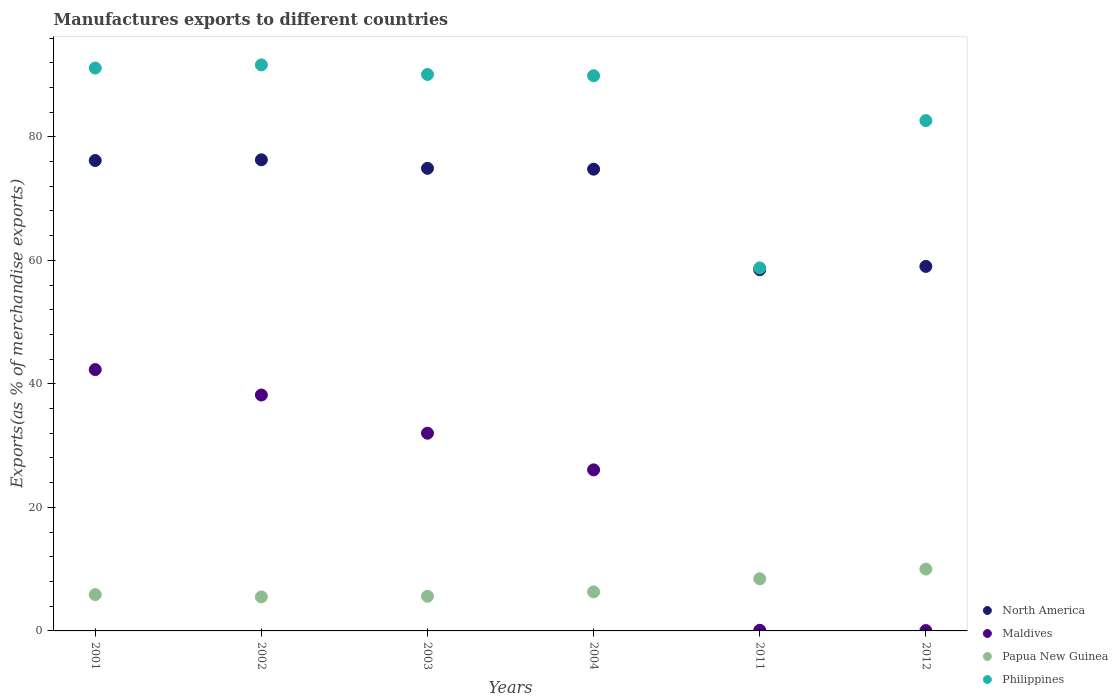How many different coloured dotlines are there?
Keep it short and to the point. 4. Is the number of dotlines equal to the number of legend labels?
Provide a succinct answer. Yes. What is the percentage of exports to different countries in Philippines in 2012?
Your answer should be compact. 82.63. Across all years, what is the maximum percentage of exports to different countries in Philippines?
Keep it short and to the point. 91.66. Across all years, what is the minimum percentage of exports to different countries in North America?
Offer a very short reply. 58.49. In which year was the percentage of exports to different countries in Papua New Guinea minimum?
Offer a very short reply. 2002. What is the total percentage of exports to different countries in Philippines in the graph?
Keep it short and to the point. 504.21. What is the difference between the percentage of exports to different countries in Philippines in 2003 and that in 2011?
Your answer should be compact. 31.33. What is the difference between the percentage of exports to different countries in Maldives in 2002 and the percentage of exports to different countries in North America in 2012?
Make the answer very short. -20.82. What is the average percentage of exports to different countries in Philippines per year?
Your answer should be compact. 84.04. In the year 2004, what is the difference between the percentage of exports to different countries in Maldives and percentage of exports to different countries in North America?
Provide a short and direct response. -48.69. What is the ratio of the percentage of exports to different countries in Papua New Guinea in 2001 to that in 2012?
Keep it short and to the point. 0.59. What is the difference between the highest and the second highest percentage of exports to different countries in Philippines?
Your answer should be compact. 0.52. What is the difference between the highest and the lowest percentage of exports to different countries in North America?
Offer a terse response. 17.79. In how many years, is the percentage of exports to different countries in Philippines greater than the average percentage of exports to different countries in Philippines taken over all years?
Your answer should be compact. 4. Is the sum of the percentage of exports to different countries in Papua New Guinea in 2004 and 2012 greater than the maximum percentage of exports to different countries in Philippines across all years?
Provide a short and direct response. No. Is it the case that in every year, the sum of the percentage of exports to different countries in North America and percentage of exports to different countries in Papua New Guinea  is greater than the sum of percentage of exports to different countries in Philippines and percentage of exports to different countries in Maldives?
Offer a very short reply. No. Is the percentage of exports to different countries in Maldives strictly less than the percentage of exports to different countries in Philippines over the years?
Your answer should be very brief. Yes. Does the graph contain grids?
Ensure brevity in your answer.  No. Where does the legend appear in the graph?
Your answer should be very brief. Bottom right. How are the legend labels stacked?
Ensure brevity in your answer.  Vertical. What is the title of the graph?
Offer a very short reply. Manufactures exports to different countries. Does "Zambia" appear as one of the legend labels in the graph?
Your answer should be compact. No. What is the label or title of the X-axis?
Provide a succinct answer. Years. What is the label or title of the Y-axis?
Give a very brief answer. Exports(as % of merchandise exports). What is the Exports(as % of merchandise exports) in North America in 2001?
Keep it short and to the point. 76.17. What is the Exports(as % of merchandise exports) in Maldives in 2001?
Offer a terse response. 42.32. What is the Exports(as % of merchandise exports) in Papua New Guinea in 2001?
Your answer should be compact. 5.88. What is the Exports(as % of merchandise exports) in Philippines in 2001?
Keep it short and to the point. 91.14. What is the Exports(as % of merchandise exports) in North America in 2002?
Make the answer very short. 76.29. What is the Exports(as % of merchandise exports) of Maldives in 2002?
Keep it short and to the point. 38.2. What is the Exports(as % of merchandise exports) of Papua New Guinea in 2002?
Your response must be concise. 5.51. What is the Exports(as % of merchandise exports) of Philippines in 2002?
Your answer should be very brief. 91.66. What is the Exports(as % of merchandise exports) of North America in 2003?
Give a very brief answer. 74.9. What is the Exports(as % of merchandise exports) of Maldives in 2003?
Keep it short and to the point. 32.02. What is the Exports(as % of merchandise exports) in Papua New Guinea in 2003?
Give a very brief answer. 5.61. What is the Exports(as % of merchandise exports) in Philippines in 2003?
Ensure brevity in your answer.  90.11. What is the Exports(as % of merchandise exports) of North America in 2004?
Offer a terse response. 74.76. What is the Exports(as % of merchandise exports) in Maldives in 2004?
Provide a short and direct response. 26.08. What is the Exports(as % of merchandise exports) of Papua New Guinea in 2004?
Keep it short and to the point. 6.32. What is the Exports(as % of merchandise exports) in Philippines in 2004?
Offer a very short reply. 89.9. What is the Exports(as % of merchandise exports) in North America in 2011?
Make the answer very short. 58.49. What is the Exports(as % of merchandise exports) of Maldives in 2011?
Offer a very short reply. 0.1. What is the Exports(as % of merchandise exports) in Papua New Guinea in 2011?
Your answer should be very brief. 8.44. What is the Exports(as % of merchandise exports) of Philippines in 2011?
Your answer should be very brief. 58.78. What is the Exports(as % of merchandise exports) of North America in 2012?
Keep it short and to the point. 59.02. What is the Exports(as % of merchandise exports) of Maldives in 2012?
Provide a succinct answer. 0.06. What is the Exports(as % of merchandise exports) of Papua New Guinea in 2012?
Offer a terse response. 10.02. What is the Exports(as % of merchandise exports) of Philippines in 2012?
Offer a very short reply. 82.63. Across all years, what is the maximum Exports(as % of merchandise exports) in North America?
Offer a very short reply. 76.29. Across all years, what is the maximum Exports(as % of merchandise exports) in Maldives?
Provide a succinct answer. 42.32. Across all years, what is the maximum Exports(as % of merchandise exports) of Papua New Guinea?
Your answer should be compact. 10.02. Across all years, what is the maximum Exports(as % of merchandise exports) in Philippines?
Your answer should be very brief. 91.66. Across all years, what is the minimum Exports(as % of merchandise exports) of North America?
Give a very brief answer. 58.49. Across all years, what is the minimum Exports(as % of merchandise exports) of Maldives?
Provide a short and direct response. 0.06. Across all years, what is the minimum Exports(as % of merchandise exports) of Papua New Guinea?
Provide a short and direct response. 5.51. Across all years, what is the minimum Exports(as % of merchandise exports) in Philippines?
Keep it short and to the point. 58.78. What is the total Exports(as % of merchandise exports) of North America in the graph?
Make the answer very short. 419.64. What is the total Exports(as % of merchandise exports) in Maldives in the graph?
Offer a terse response. 138.78. What is the total Exports(as % of merchandise exports) in Papua New Guinea in the graph?
Ensure brevity in your answer.  41.78. What is the total Exports(as % of merchandise exports) in Philippines in the graph?
Ensure brevity in your answer.  504.21. What is the difference between the Exports(as % of merchandise exports) of North America in 2001 and that in 2002?
Keep it short and to the point. -0.12. What is the difference between the Exports(as % of merchandise exports) of Maldives in 2001 and that in 2002?
Your response must be concise. 4.12. What is the difference between the Exports(as % of merchandise exports) of Papua New Guinea in 2001 and that in 2002?
Give a very brief answer. 0.37. What is the difference between the Exports(as % of merchandise exports) in Philippines in 2001 and that in 2002?
Offer a terse response. -0.52. What is the difference between the Exports(as % of merchandise exports) in North America in 2001 and that in 2003?
Your answer should be compact. 1.27. What is the difference between the Exports(as % of merchandise exports) in Maldives in 2001 and that in 2003?
Make the answer very short. 10.3. What is the difference between the Exports(as % of merchandise exports) of Papua New Guinea in 2001 and that in 2003?
Your response must be concise. 0.28. What is the difference between the Exports(as % of merchandise exports) in Philippines in 2001 and that in 2003?
Offer a very short reply. 1.04. What is the difference between the Exports(as % of merchandise exports) in North America in 2001 and that in 2004?
Provide a succinct answer. 1.4. What is the difference between the Exports(as % of merchandise exports) of Maldives in 2001 and that in 2004?
Your response must be concise. 16.24. What is the difference between the Exports(as % of merchandise exports) in Papua New Guinea in 2001 and that in 2004?
Make the answer very short. -0.44. What is the difference between the Exports(as % of merchandise exports) of Philippines in 2001 and that in 2004?
Offer a terse response. 1.25. What is the difference between the Exports(as % of merchandise exports) of North America in 2001 and that in 2011?
Provide a short and direct response. 17.68. What is the difference between the Exports(as % of merchandise exports) of Maldives in 2001 and that in 2011?
Provide a succinct answer. 42.22. What is the difference between the Exports(as % of merchandise exports) in Papua New Guinea in 2001 and that in 2011?
Keep it short and to the point. -2.56. What is the difference between the Exports(as % of merchandise exports) in Philippines in 2001 and that in 2011?
Ensure brevity in your answer.  32.36. What is the difference between the Exports(as % of merchandise exports) of North America in 2001 and that in 2012?
Provide a short and direct response. 17.15. What is the difference between the Exports(as % of merchandise exports) in Maldives in 2001 and that in 2012?
Make the answer very short. 42.26. What is the difference between the Exports(as % of merchandise exports) in Papua New Guinea in 2001 and that in 2012?
Provide a succinct answer. -4.13. What is the difference between the Exports(as % of merchandise exports) in Philippines in 2001 and that in 2012?
Make the answer very short. 8.51. What is the difference between the Exports(as % of merchandise exports) of North America in 2002 and that in 2003?
Ensure brevity in your answer.  1.38. What is the difference between the Exports(as % of merchandise exports) of Maldives in 2002 and that in 2003?
Provide a short and direct response. 6.18. What is the difference between the Exports(as % of merchandise exports) of Papua New Guinea in 2002 and that in 2003?
Keep it short and to the point. -0.09. What is the difference between the Exports(as % of merchandise exports) of Philippines in 2002 and that in 2003?
Provide a short and direct response. 1.55. What is the difference between the Exports(as % of merchandise exports) in North America in 2002 and that in 2004?
Offer a terse response. 1.52. What is the difference between the Exports(as % of merchandise exports) of Maldives in 2002 and that in 2004?
Make the answer very short. 12.12. What is the difference between the Exports(as % of merchandise exports) in Papua New Guinea in 2002 and that in 2004?
Your answer should be very brief. -0.81. What is the difference between the Exports(as % of merchandise exports) in Philippines in 2002 and that in 2004?
Offer a terse response. 1.76. What is the difference between the Exports(as % of merchandise exports) in North America in 2002 and that in 2011?
Provide a short and direct response. 17.79. What is the difference between the Exports(as % of merchandise exports) in Maldives in 2002 and that in 2011?
Provide a succinct answer. 38.1. What is the difference between the Exports(as % of merchandise exports) in Papua New Guinea in 2002 and that in 2011?
Make the answer very short. -2.93. What is the difference between the Exports(as % of merchandise exports) of Philippines in 2002 and that in 2011?
Your answer should be very brief. 32.88. What is the difference between the Exports(as % of merchandise exports) in North America in 2002 and that in 2012?
Provide a succinct answer. 17.26. What is the difference between the Exports(as % of merchandise exports) of Maldives in 2002 and that in 2012?
Make the answer very short. 38.14. What is the difference between the Exports(as % of merchandise exports) of Papua New Guinea in 2002 and that in 2012?
Offer a terse response. -4.5. What is the difference between the Exports(as % of merchandise exports) in Philippines in 2002 and that in 2012?
Your answer should be compact. 9.02. What is the difference between the Exports(as % of merchandise exports) of North America in 2003 and that in 2004?
Your response must be concise. 0.14. What is the difference between the Exports(as % of merchandise exports) in Maldives in 2003 and that in 2004?
Offer a terse response. 5.94. What is the difference between the Exports(as % of merchandise exports) in Papua New Guinea in 2003 and that in 2004?
Offer a terse response. -0.71. What is the difference between the Exports(as % of merchandise exports) in Philippines in 2003 and that in 2004?
Keep it short and to the point. 0.21. What is the difference between the Exports(as % of merchandise exports) of North America in 2003 and that in 2011?
Your answer should be very brief. 16.41. What is the difference between the Exports(as % of merchandise exports) of Maldives in 2003 and that in 2011?
Ensure brevity in your answer.  31.91. What is the difference between the Exports(as % of merchandise exports) of Papua New Guinea in 2003 and that in 2011?
Make the answer very short. -2.83. What is the difference between the Exports(as % of merchandise exports) of Philippines in 2003 and that in 2011?
Your answer should be compact. 31.33. What is the difference between the Exports(as % of merchandise exports) of North America in 2003 and that in 2012?
Give a very brief answer. 15.88. What is the difference between the Exports(as % of merchandise exports) of Maldives in 2003 and that in 2012?
Give a very brief answer. 31.96. What is the difference between the Exports(as % of merchandise exports) of Papua New Guinea in 2003 and that in 2012?
Give a very brief answer. -4.41. What is the difference between the Exports(as % of merchandise exports) in Philippines in 2003 and that in 2012?
Make the answer very short. 7.47. What is the difference between the Exports(as % of merchandise exports) in North America in 2004 and that in 2011?
Provide a succinct answer. 16.27. What is the difference between the Exports(as % of merchandise exports) of Maldives in 2004 and that in 2011?
Offer a terse response. 25.98. What is the difference between the Exports(as % of merchandise exports) of Papua New Guinea in 2004 and that in 2011?
Your response must be concise. -2.12. What is the difference between the Exports(as % of merchandise exports) in Philippines in 2004 and that in 2011?
Make the answer very short. 31.12. What is the difference between the Exports(as % of merchandise exports) in North America in 2004 and that in 2012?
Give a very brief answer. 15.74. What is the difference between the Exports(as % of merchandise exports) of Maldives in 2004 and that in 2012?
Offer a terse response. 26.02. What is the difference between the Exports(as % of merchandise exports) in Papua New Guinea in 2004 and that in 2012?
Offer a terse response. -3.69. What is the difference between the Exports(as % of merchandise exports) in Philippines in 2004 and that in 2012?
Your answer should be very brief. 7.26. What is the difference between the Exports(as % of merchandise exports) in North America in 2011 and that in 2012?
Give a very brief answer. -0.53. What is the difference between the Exports(as % of merchandise exports) of Maldives in 2011 and that in 2012?
Give a very brief answer. 0.05. What is the difference between the Exports(as % of merchandise exports) of Papua New Guinea in 2011 and that in 2012?
Keep it short and to the point. -1.57. What is the difference between the Exports(as % of merchandise exports) in Philippines in 2011 and that in 2012?
Your answer should be compact. -23.86. What is the difference between the Exports(as % of merchandise exports) in North America in 2001 and the Exports(as % of merchandise exports) in Maldives in 2002?
Keep it short and to the point. 37.97. What is the difference between the Exports(as % of merchandise exports) in North America in 2001 and the Exports(as % of merchandise exports) in Papua New Guinea in 2002?
Offer a terse response. 70.66. What is the difference between the Exports(as % of merchandise exports) in North America in 2001 and the Exports(as % of merchandise exports) in Philippines in 2002?
Your answer should be compact. -15.49. What is the difference between the Exports(as % of merchandise exports) in Maldives in 2001 and the Exports(as % of merchandise exports) in Papua New Guinea in 2002?
Provide a succinct answer. 36.81. What is the difference between the Exports(as % of merchandise exports) of Maldives in 2001 and the Exports(as % of merchandise exports) of Philippines in 2002?
Provide a succinct answer. -49.34. What is the difference between the Exports(as % of merchandise exports) of Papua New Guinea in 2001 and the Exports(as % of merchandise exports) of Philippines in 2002?
Make the answer very short. -85.77. What is the difference between the Exports(as % of merchandise exports) in North America in 2001 and the Exports(as % of merchandise exports) in Maldives in 2003?
Keep it short and to the point. 44.15. What is the difference between the Exports(as % of merchandise exports) in North America in 2001 and the Exports(as % of merchandise exports) in Papua New Guinea in 2003?
Provide a succinct answer. 70.56. What is the difference between the Exports(as % of merchandise exports) of North America in 2001 and the Exports(as % of merchandise exports) of Philippines in 2003?
Your answer should be compact. -13.94. What is the difference between the Exports(as % of merchandise exports) in Maldives in 2001 and the Exports(as % of merchandise exports) in Papua New Guinea in 2003?
Offer a terse response. 36.71. What is the difference between the Exports(as % of merchandise exports) in Maldives in 2001 and the Exports(as % of merchandise exports) in Philippines in 2003?
Keep it short and to the point. -47.79. What is the difference between the Exports(as % of merchandise exports) of Papua New Guinea in 2001 and the Exports(as % of merchandise exports) of Philippines in 2003?
Your answer should be compact. -84.22. What is the difference between the Exports(as % of merchandise exports) in North America in 2001 and the Exports(as % of merchandise exports) in Maldives in 2004?
Your answer should be compact. 50.09. What is the difference between the Exports(as % of merchandise exports) of North America in 2001 and the Exports(as % of merchandise exports) of Papua New Guinea in 2004?
Your answer should be compact. 69.85. What is the difference between the Exports(as % of merchandise exports) of North America in 2001 and the Exports(as % of merchandise exports) of Philippines in 2004?
Your answer should be compact. -13.73. What is the difference between the Exports(as % of merchandise exports) in Maldives in 2001 and the Exports(as % of merchandise exports) in Papua New Guinea in 2004?
Offer a very short reply. 36. What is the difference between the Exports(as % of merchandise exports) of Maldives in 2001 and the Exports(as % of merchandise exports) of Philippines in 2004?
Your response must be concise. -47.58. What is the difference between the Exports(as % of merchandise exports) in Papua New Guinea in 2001 and the Exports(as % of merchandise exports) in Philippines in 2004?
Ensure brevity in your answer.  -84.01. What is the difference between the Exports(as % of merchandise exports) of North America in 2001 and the Exports(as % of merchandise exports) of Maldives in 2011?
Offer a terse response. 76.07. What is the difference between the Exports(as % of merchandise exports) of North America in 2001 and the Exports(as % of merchandise exports) of Papua New Guinea in 2011?
Your response must be concise. 67.73. What is the difference between the Exports(as % of merchandise exports) in North America in 2001 and the Exports(as % of merchandise exports) in Philippines in 2011?
Ensure brevity in your answer.  17.39. What is the difference between the Exports(as % of merchandise exports) of Maldives in 2001 and the Exports(as % of merchandise exports) of Papua New Guinea in 2011?
Provide a succinct answer. 33.88. What is the difference between the Exports(as % of merchandise exports) in Maldives in 2001 and the Exports(as % of merchandise exports) in Philippines in 2011?
Make the answer very short. -16.46. What is the difference between the Exports(as % of merchandise exports) in Papua New Guinea in 2001 and the Exports(as % of merchandise exports) in Philippines in 2011?
Provide a succinct answer. -52.9. What is the difference between the Exports(as % of merchandise exports) of North America in 2001 and the Exports(as % of merchandise exports) of Maldives in 2012?
Keep it short and to the point. 76.11. What is the difference between the Exports(as % of merchandise exports) of North America in 2001 and the Exports(as % of merchandise exports) of Papua New Guinea in 2012?
Give a very brief answer. 66.15. What is the difference between the Exports(as % of merchandise exports) in North America in 2001 and the Exports(as % of merchandise exports) in Philippines in 2012?
Ensure brevity in your answer.  -6.46. What is the difference between the Exports(as % of merchandise exports) of Maldives in 2001 and the Exports(as % of merchandise exports) of Papua New Guinea in 2012?
Offer a very short reply. 32.3. What is the difference between the Exports(as % of merchandise exports) in Maldives in 2001 and the Exports(as % of merchandise exports) in Philippines in 2012?
Ensure brevity in your answer.  -40.31. What is the difference between the Exports(as % of merchandise exports) in Papua New Guinea in 2001 and the Exports(as % of merchandise exports) in Philippines in 2012?
Offer a very short reply. -76.75. What is the difference between the Exports(as % of merchandise exports) in North America in 2002 and the Exports(as % of merchandise exports) in Maldives in 2003?
Your answer should be compact. 44.27. What is the difference between the Exports(as % of merchandise exports) of North America in 2002 and the Exports(as % of merchandise exports) of Papua New Guinea in 2003?
Your answer should be compact. 70.68. What is the difference between the Exports(as % of merchandise exports) in North America in 2002 and the Exports(as % of merchandise exports) in Philippines in 2003?
Your response must be concise. -13.82. What is the difference between the Exports(as % of merchandise exports) in Maldives in 2002 and the Exports(as % of merchandise exports) in Papua New Guinea in 2003?
Your answer should be compact. 32.59. What is the difference between the Exports(as % of merchandise exports) in Maldives in 2002 and the Exports(as % of merchandise exports) in Philippines in 2003?
Your response must be concise. -51.9. What is the difference between the Exports(as % of merchandise exports) of Papua New Guinea in 2002 and the Exports(as % of merchandise exports) of Philippines in 2003?
Offer a terse response. -84.59. What is the difference between the Exports(as % of merchandise exports) of North America in 2002 and the Exports(as % of merchandise exports) of Maldives in 2004?
Your response must be concise. 50.21. What is the difference between the Exports(as % of merchandise exports) in North America in 2002 and the Exports(as % of merchandise exports) in Papua New Guinea in 2004?
Make the answer very short. 69.96. What is the difference between the Exports(as % of merchandise exports) in North America in 2002 and the Exports(as % of merchandise exports) in Philippines in 2004?
Make the answer very short. -13.61. What is the difference between the Exports(as % of merchandise exports) in Maldives in 2002 and the Exports(as % of merchandise exports) in Papua New Guinea in 2004?
Make the answer very short. 31.88. What is the difference between the Exports(as % of merchandise exports) in Maldives in 2002 and the Exports(as % of merchandise exports) in Philippines in 2004?
Provide a short and direct response. -51.7. What is the difference between the Exports(as % of merchandise exports) of Papua New Guinea in 2002 and the Exports(as % of merchandise exports) of Philippines in 2004?
Provide a short and direct response. -84.38. What is the difference between the Exports(as % of merchandise exports) of North America in 2002 and the Exports(as % of merchandise exports) of Maldives in 2011?
Your answer should be very brief. 76.18. What is the difference between the Exports(as % of merchandise exports) in North America in 2002 and the Exports(as % of merchandise exports) in Papua New Guinea in 2011?
Your answer should be very brief. 67.84. What is the difference between the Exports(as % of merchandise exports) of North America in 2002 and the Exports(as % of merchandise exports) of Philippines in 2011?
Offer a very short reply. 17.51. What is the difference between the Exports(as % of merchandise exports) in Maldives in 2002 and the Exports(as % of merchandise exports) in Papua New Guinea in 2011?
Ensure brevity in your answer.  29.76. What is the difference between the Exports(as % of merchandise exports) in Maldives in 2002 and the Exports(as % of merchandise exports) in Philippines in 2011?
Offer a terse response. -20.58. What is the difference between the Exports(as % of merchandise exports) of Papua New Guinea in 2002 and the Exports(as % of merchandise exports) of Philippines in 2011?
Offer a very short reply. -53.27. What is the difference between the Exports(as % of merchandise exports) of North America in 2002 and the Exports(as % of merchandise exports) of Maldives in 2012?
Offer a terse response. 76.23. What is the difference between the Exports(as % of merchandise exports) in North America in 2002 and the Exports(as % of merchandise exports) in Papua New Guinea in 2012?
Your answer should be compact. 66.27. What is the difference between the Exports(as % of merchandise exports) in North America in 2002 and the Exports(as % of merchandise exports) in Philippines in 2012?
Offer a very short reply. -6.35. What is the difference between the Exports(as % of merchandise exports) of Maldives in 2002 and the Exports(as % of merchandise exports) of Papua New Guinea in 2012?
Your response must be concise. 28.18. What is the difference between the Exports(as % of merchandise exports) of Maldives in 2002 and the Exports(as % of merchandise exports) of Philippines in 2012?
Your response must be concise. -44.43. What is the difference between the Exports(as % of merchandise exports) in Papua New Guinea in 2002 and the Exports(as % of merchandise exports) in Philippines in 2012?
Offer a very short reply. -77.12. What is the difference between the Exports(as % of merchandise exports) of North America in 2003 and the Exports(as % of merchandise exports) of Maldives in 2004?
Provide a succinct answer. 48.83. What is the difference between the Exports(as % of merchandise exports) in North America in 2003 and the Exports(as % of merchandise exports) in Papua New Guinea in 2004?
Make the answer very short. 68.58. What is the difference between the Exports(as % of merchandise exports) in North America in 2003 and the Exports(as % of merchandise exports) in Philippines in 2004?
Your response must be concise. -14.99. What is the difference between the Exports(as % of merchandise exports) in Maldives in 2003 and the Exports(as % of merchandise exports) in Papua New Guinea in 2004?
Your answer should be very brief. 25.69. What is the difference between the Exports(as % of merchandise exports) of Maldives in 2003 and the Exports(as % of merchandise exports) of Philippines in 2004?
Your answer should be very brief. -57.88. What is the difference between the Exports(as % of merchandise exports) in Papua New Guinea in 2003 and the Exports(as % of merchandise exports) in Philippines in 2004?
Offer a very short reply. -84.29. What is the difference between the Exports(as % of merchandise exports) in North America in 2003 and the Exports(as % of merchandise exports) in Maldives in 2011?
Offer a terse response. 74.8. What is the difference between the Exports(as % of merchandise exports) in North America in 2003 and the Exports(as % of merchandise exports) in Papua New Guinea in 2011?
Offer a very short reply. 66.46. What is the difference between the Exports(as % of merchandise exports) of North America in 2003 and the Exports(as % of merchandise exports) of Philippines in 2011?
Provide a short and direct response. 16.13. What is the difference between the Exports(as % of merchandise exports) in Maldives in 2003 and the Exports(as % of merchandise exports) in Papua New Guinea in 2011?
Offer a very short reply. 23.58. What is the difference between the Exports(as % of merchandise exports) in Maldives in 2003 and the Exports(as % of merchandise exports) in Philippines in 2011?
Offer a very short reply. -26.76. What is the difference between the Exports(as % of merchandise exports) in Papua New Guinea in 2003 and the Exports(as % of merchandise exports) in Philippines in 2011?
Your answer should be very brief. -53.17. What is the difference between the Exports(as % of merchandise exports) in North America in 2003 and the Exports(as % of merchandise exports) in Maldives in 2012?
Provide a succinct answer. 74.85. What is the difference between the Exports(as % of merchandise exports) of North America in 2003 and the Exports(as % of merchandise exports) of Papua New Guinea in 2012?
Provide a succinct answer. 64.89. What is the difference between the Exports(as % of merchandise exports) of North America in 2003 and the Exports(as % of merchandise exports) of Philippines in 2012?
Offer a very short reply. -7.73. What is the difference between the Exports(as % of merchandise exports) in Maldives in 2003 and the Exports(as % of merchandise exports) in Papua New Guinea in 2012?
Offer a very short reply. 22. What is the difference between the Exports(as % of merchandise exports) of Maldives in 2003 and the Exports(as % of merchandise exports) of Philippines in 2012?
Offer a terse response. -50.62. What is the difference between the Exports(as % of merchandise exports) of Papua New Guinea in 2003 and the Exports(as % of merchandise exports) of Philippines in 2012?
Provide a succinct answer. -77.03. What is the difference between the Exports(as % of merchandise exports) of North America in 2004 and the Exports(as % of merchandise exports) of Maldives in 2011?
Make the answer very short. 74.66. What is the difference between the Exports(as % of merchandise exports) in North America in 2004 and the Exports(as % of merchandise exports) in Papua New Guinea in 2011?
Provide a succinct answer. 66.32. What is the difference between the Exports(as % of merchandise exports) of North America in 2004 and the Exports(as % of merchandise exports) of Philippines in 2011?
Offer a very short reply. 15.99. What is the difference between the Exports(as % of merchandise exports) in Maldives in 2004 and the Exports(as % of merchandise exports) in Papua New Guinea in 2011?
Your response must be concise. 17.64. What is the difference between the Exports(as % of merchandise exports) of Maldives in 2004 and the Exports(as % of merchandise exports) of Philippines in 2011?
Offer a very short reply. -32.7. What is the difference between the Exports(as % of merchandise exports) of Papua New Guinea in 2004 and the Exports(as % of merchandise exports) of Philippines in 2011?
Your response must be concise. -52.46. What is the difference between the Exports(as % of merchandise exports) in North America in 2004 and the Exports(as % of merchandise exports) in Maldives in 2012?
Provide a succinct answer. 74.71. What is the difference between the Exports(as % of merchandise exports) in North America in 2004 and the Exports(as % of merchandise exports) in Papua New Guinea in 2012?
Provide a short and direct response. 64.75. What is the difference between the Exports(as % of merchandise exports) in North America in 2004 and the Exports(as % of merchandise exports) in Philippines in 2012?
Your answer should be compact. -7.87. What is the difference between the Exports(as % of merchandise exports) in Maldives in 2004 and the Exports(as % of merchandise exports) in Papua New Guinea in 2012?
Offer a terse response. 16.06. What is the difference between the Exports(as % of merchandise exports) of Maldives in 2004 and the Exports(as % of merchandise exports) of Philippines in 2012?
Your answer should be compact. -56.55. What is the difference between the Exports(as % of merchandise exports) of Papua New Guinea in 2004 and the Exports(as % of merchandise exports) of Philippines in 2012?
Give a very brief answer. -76.31. What is the difference between the Exports(as % of merchandise exports) of North America in 2011 and the Exports(as % of merchandise exports) of Maldives in 2012?
Provide a succinct answer. 58.44. What is the difference between the Exports(as % of merchandise exports) in North America in 2011 and the Exports(as % of merchandise exports) in Papua New Guinea in 2012?
Provide a succinct answer. 48.48. What is the difference between the Exports(as % of merchandise exports) of North America in 2011 and the Exports(as % of merchandise exports) of Philippines in 2012?
Make the answer very short. -24.14. What is the difference between the Exports(as % of merchandise exports) in Maldives in 2011 and the Exports(as % of merchandise exports) in Papua New Guinea in 2012?
Offer a terse response. -9.91. What is the difference between the Exports(as % of merchandise exports) of Maldives in 2011 and the Exports(as % of merchandise exports) of Philippines in 2012?
Make the answer very short. -82.53. What is the difference between the Exports(as % of merchandise exports) in Papua New Guinea in 2011 and the Exports(as % of merchandise exports) in Philippines in 2012?
Ensure brevity in your answer.  -74.19. What is the average Exports(as % of merchandise exports) of North America per year?
Ensure brevity in your answer.  69.94. What is the average Exports(as % of merchandise exports) of Maldives per year?
Give a very brief answer. 23.13. What is the average Exports(as % of merchandise exports) of Papua New Guinea per year?
Make the answer very short. 6.96. What is the average Exports(as % of merchandise exports) in Philippines per year?
Give a very brief answer. 84.04. In the year 2001, what is the difference between the Exports(as % of merchandise exports) in North America and Exports(as % of merchandise exports) in Maldives?
Your response must be concise. 33.85. In the year 2001, what is the difference between the Exports(as % of merchandise exports) in North America and Exports(as % of merchandise exports) in Papua New Guinea?
Ensure brevity in your answer.  70.29. In the year 2001, what is the difference between the Exports(as % of merchandise exports) in North America and Exports(as % of merchandise exports) in Philippines?
Provide a short and direct response. -14.97. In the year 2001, what is the difference between the Exports(as % of merchandise exports) of Maldives and Exports(as % of merchandise exports) of Papua New Guinea?
Ensure brevity in your answer.  36.44. In the year 2001, what is the difference between the Exports(as % of merchandise exports) in Maldives and Exports(as % of merchandise exports) in Philippines?
Your answer should be very brief. -48.82. In the year 2001, what is the difference between the Exports(as % of merchandise exports) of Papua New Guinea and Exports(as % of merchandise exports) of Philippines?
Keep it short and to the point. -85.26. In the year 2002, what is the difference between the Exports(as % of merchandise exports) in North America and Exports(as % of merchandise exports) in Maldives?
Offer a very short reply. 38.09. In the year 2002, what is the difference between the Exports(as % of merchandise exports) of North America and Exports(as % of merchandise exports) of Papua New Guinea?
Your answer should be compact. 70.77. In the year 2002, what is the difference between the Exports(as % of merchandise exports) of North America and Exports(as % of merchandise exports) of Philippines?
Keep it short and to the point. -15.37. In the year 2002, what is the difference between the Exports(as % of merchandise exports) in Maldives and Exports(as % of merchandise exports) in Papua New Guinea?
Keep it short and to the point. 32.69. In the year 2002, what is the difference between the Exports(as % of merchandise exports) in Maldives and Exports(as % of merchandise exports) in Philippines?
Give a very brief answer. -53.46. In the year 2002, what is the difference between the Exports(as % of merchandise exports) in Papua New Guinea and Exports(as % of merchandise exports) in Philippines?
Your answer should be very brief. -86.14. In the year 2003, what is the difference between the Exports(as % of merchandise exports) in North America and Exports(as % of merchandise exports) in Maldives?
Provide a short and direct response. 42.89. In the year 2003, what is the difference between the Exports(as % of merchandise exports) in North America and Exports(as % of merchandise exports) in Papua New Guinea?
Offer a terse response. 69.3. In the year 2003, what is the difference between the Exports(as % of merchandise exports) of North America and Exports(as % of merchandise exports) of Philippines?
Provide a short and direct response. -15.2. In the year 2003, what is the difference between the Exports(as % of merchandise exports) of Maldives and Exports(as % of merchandise exports) of Papua New Guinea?
Provide a succinct answer. 26.41. In the year 2003, what is the difference between the Exports(as % of merchandise exports) of Maldives and Exports(as % of merchandise exports) of Philippines?
Give a very brief answer. -58.09. In the year 2003, what is the difference between the Exports(as % of merchandise exports) of Papua New Guinea and Exports(as % of merchandise exports) of Philippines?
Your response must be concise. -84.5. In the year 2004, what is the difference between the Exports(as % of merchandise exports) in North America and Exports(as % of merchandise exports) in Maldives?
Ensure brevity in your answer.  48.69. In the year 2004, what is the difference between the Exports(as % of merchandise exports) of North America and Exports(as % of merchandise exports) of Papua New Guinea?
Offer a terse response. 68.44. In the year 2004, what is the difference between the Exports(as % of merchandise exports) in North America and Exports(as % of merchandise exports) in Philippines?
Your answer should be compact. -15.13. In the year 2004, what is the difference between the Exports(as % of merchandise exports) of Maldives and Exports(as % of merchandise exports) of Papua New Guinea?
Keep it short and to the point. 19.76. In the year 2004, what is the difference between the Exports(as % of merchandise exports) in Maldives and Exports(as % of merchandise exports) in Philippines?
Keep it short and to the point. -63.82. In the year 2004, what is the difference between the Exports(as % of merchandise exports) of Papua New Guinea and Exports(as % of merchandise exports) of Philippines?
Provide a short and direct response. -83.58. In the year 2011, what is the difference between the Exports(as % of merchandise exports) of North America and Exports(as % of merchandise exports) of Maldives?
Provide a short and direct response. 58.39. In the year 2011, what is the difference between the Exports(as % of merchandise exports) in North America and Exports(as % of merchandise exports) in Papua New Guinea?
Ensure brevity in your answer.  50.05. In the year 2011, what is the difference between the Exports(as % of merchandise exports) in North America and Exports(as % of merchandise exports) in Philippines?
Ensure brevity in your answer.  -0.29. In the year 2011, what is the difference between the Exports(as % of merchandise exports) of Maldives and Exports(as % of merchandise exports) of Papua New Guinea?
Offer a very short reply. -8.34. In the year 2011, what is the difference between the Exports(as % of merchandise exports) in Maldives and Exports(as % of merchandise exports) in Philippines?
Offer a terse response. -58.68. In the year 2011, what is the difference between the Exports(as % of merchandise exports) in Papua New Guinea and Exports(as % of merchandise exports) in Philippines?
Your response must be concise. -50.34. In the year 2012, what is the difference between the Exports(as % of merchandise exports) in North America and Exports(as % of merchandise exports) in Maldives?
Provide a short and direct response. 58.96. In the year 2012, what is the difference between the Exports(as % of merchandise exports) of North America and Exports(as % of merchandise exports) of Papua New Guinea?
Provide a succinct answer. 49.01. In the year 2012, what is the difference between the Exports(as % of merchandise exports) of North America and Exports(as % of merchandise exports) of Philippines?
Keep it short and to the point. -23.61. In the year 2012, what is the difference between the Exports(as % of merchandise exports) of Maldives and Exports(as % of merchandise exports) of Papua New Guinea?
Provide a short and direct response. -9.96. In the year 2012, what is the difference between the Exports(as % of merchandise exports) of Maldives and Exports(as % of merchandise exports) of Philippines?
Your response must be concise. -82.58. In the year 2012, what is the difference between the Exports(as % of merchandise exports) of Papua New Guinea and Exports(as % of merchandise exports) of Philippines?
Offer a very short reply. -72.62. What is the ratio of the Exports(as % of merchandise exports) of North America in 2001 to that in 2002?
Give a very brief answer. 1. What is the ratio of the Exports(as % of merchandise exports) of Maldives in 2001 to that in 2002?
Ensure brevity in your answer.  1.11. What is the ratio of the Exports(as % of merchandise exports) of Papua New Guinea in 2001 to that in 2002?
Ensure brevity in your answer.  1.07. What is the ratio of the Exports(as % of merchandise exports) in Philippines in 2001 to that in 2002?
Your answer should be compact. 0.99. What is the ratio of the Exports(as % of merchandise exports) of North America in 2001 to that in 2003?
Your answer should be compact. 1.02. What is the ratio of the Exports(as % of merchandise exports) of Maldives in 2001 to that in 2003?
Give a very brief answer. 1.32. What is the ratio of the Exports(as % of merchandise exports) of Papua New Guinea in 2001 to that in 2003?
Your answer should be very brief. 1.05. What is the ratio of the Exports(as % of merchandise exports) in Philippines in 2001 to that in 2003?
Provide a succinct answer. 1.01. What is the ratio of the Exports(as % of merchandise exports) in North America in 2001 to that in 2004?
Offer a terse response. 1.02. What is the ratio of the Exports(as % of merchandise exports) in Maldives in 2001 to that in 2004?
Your response must be concise. 1.62. What is the ratio of the Exports(as % of merchandise exports) in Papua New Guinea in 2001 to that in 2004?
Your answer should be very brief. 0.93. What is the ratio of the Exports(as % of merchandise exports) of Philippines in 2001 to that in 2004?
Offer a very short reply. 1.01. What is the ratio of the Exports(as % of merchandise exports) in North America in 2001 to that in 2011?
Your response must be concise. 1.3. What is the ratio of the Exports(as % of merchandise exports) of Maldives in 2001 to that in 2011?
Your answer should be compact. 410.11. What is the ratio of the Exports(as % of merchandise exports) of Papua New Guinea in 2001 to that in 2011?
Provide a short and direct response. 0.7. What is the ratio of the Exports(as % of merchandise exports) in Philippines in 2001 to that in 2011?
Your answer should be compact. 1.55. What is the ratio of the Exports(as % of merchandise exports) of North America in 2001 to that in 2012?
Offer a terse response. 1.29. What is the ratio of the Exports(as % of merchandise exports) of Maldives in 2001 to that in 2012?
Provide a short and direct response. 729.51. What is the ratio of the Exports(as % of merchandise exports) in Papua New Guinea in 2001 to that in 2012?
Your response must be concise. 0.59. What is the ratio of the Exports(as % of merchandise exports) of Philippines in 2001 to that in 2012?
Offer a terse response. 1.1. What is the ratio of the Exports(as % of merchandise exports) in North America in 2002 to that in 2003?
Provide a short and direct response. 1.02. What is the ratio of the Exports(as % of merchandise exports) of Maldives in 2002 to that in 2003?
Your answer should be very brief. 1.19. What is the ratio of the Exports(as % of merchandise exports) of Papua New Guinea in 2002 to that in 2003?
Make the answer very short. 0.98. What is the ratio of the Exports(as % of merchandise exports) in Philippines in 2002 to that in 2003?
Your response must be concise. 1.02. What is the ratio of the Exports(as % of merchandise exports) in North America in 2002 to that in 2004?
Keep it short and to the point. 1.02. What is the ratio of the Exports(as % of merchandise exports) of Maldives in 2002 to that in 2004?
Your answer should be very brief. 1.46. What is the ratio of the Exports(as % of merchandise exports) of Papua New Guinea in 2002 to that in 2004?
Offer a very short reply. 0.87. What is the ratio of the Exports(as % of merchandise exports) in Philippines in 2002 to that in 2004?
Your response must be concise. 1.02. What is the ratio of the Exports(as % of merchandise exports) of North America in 2002 to that in 2011?
Provide a short and direct response. 1.3. What is the ratio of the Exports(as % of merchandise exports) of Maldives in 2002 to that in 2011?
Your answer should be compact. 370.2. What is the ratio of the Exports(as % of merchandise exports) in Papua New Guinea in 2002 to that in 2011?
Give a very brief answer. 0.65. What is the ratio of the Exports(as % of merchandise exports) in Philippines in 2002 to that in 2011?
Provide a succinct answer. 1.56. What is the ratio of the Exports(as % of merchandise exports) of North America in 2002 to that in 2012?
Provide a short and direct response. 1.29. What is the ratio of the Exports(as % of merchandise exports) of Maldives in 2002 to that in 2012?
Offer a terse response. 658.51. What is the ratio of the Exports(as % of merchandise exports) in Papua New Guinea in 2002 to that in 2012?
Offer a very short reply. 0.55. What is the ratio of the Exports(as % of merchandise exports) in Philippines in 2002 to that in 2012?
Give a very brief answer. 1.11. What is the ratio of the Exports(as % of merchandise exports) of Maldives in 2003 to that in 2004?
Keep it short and to the point. 1.23. What is the ratio of the Exports(as % of merchandise exports) of Papua New Guinea in 2003 to that in 2004?
Provide a succinct answer. 0.89. What is the ratio of the Exports(as % of merchandise exports) in Philippines in 2003 to that in 2004?
Ensure brevity in your answer.  1. What is the ratio of the Exports(as % of merchandise exports) in North America in 2003 to that in 2011?
Offer a terse response. 1.28. What is the ratio of the Exports(as % of merchandise exports) of Maldives in 2003 to that in 2011?
Your answer should be compact. 310.27. What is the ratio of the Exports(as % of merchandise exports) of Papua New Guinea in 2003 to that in 2011?
Offer a very short reply. 0.66. What is the ratio of the Exports(as % of merchandise exports) in Philippines in 2003 to that in 2011?
Keep it short and to the point. 1.53. What is the ratio of the Exports(as % of merchandise exports) of North America in 2003 to that in 2012?
Keep it short and to the point. 1.27. What is the ratio of the Exports(as % of merchandise exports) in Maldives in 2003 to that in 2012?
Your response must be concise. 551.91. What is the ratio of the Exports(as % of merchandise exports) in Papua New Guinea in 2003 to that in 2012?
Ensure brevity in your answer.  0.56. What is the ratio of the Exports(as % of merchandise exports) of Philippines in 2003 to that in 2012?
Offer a terse response. 1.09. What is the ratio of the Exports(as % of merchandise exports) of North America in 2004 to that in 2011?
Offer a terse response. 1.28. What is the ratio of the Exports(as % of merchandise exports) in Maldives in 2004 to that in 2011?
Your response must be concise. 252.74. What is the ratio of the Exports(as % of merchandise exports) of Papua New Guinea in 2004 to that in 2011?
Keep it short and to the point. 0.75. What is the ratio of the Exports(as % of merchandise exports) of Philippines in 2004 to that in 2011?
Ensure brevity in your answer.  1.53. What is the ratio of the Exports(as % of merchandise exports) in North America in 2004 to that in 2012?
Ensure brevity in your answer.  1.27. What is the ratio of the Exports(as % of merchandise exports) in Maldives in 2004 to that in 2012?
Your answer should be compact. 449.56. What is the ratio of the Exports(as % of merchandise exports) in Papua New Guinea in 2004 to that in 2012?
Your answer should be compact. 0.63. What is the ratio of the Exports(as % of merchandise exports) of Philippines in 2004 to that in 2012?
Your answer should be very brief. 1.09. What is the ratio of the Exports(as % of merchandise exports) of Maldives in 2011 to that in 2012?
Offer a very short reply. 1.78. What is the ratio of the Exports(as % of merchandise exports) of Papua New Guinea in 2011 to that in 2012?
Offer a very short reply. 0.84. What is the ratio of the Exports(as % of merchandise exports) of Philippines in 2011 to that in 2012?
Your answer should be very brief. 0.71. What is the difference between the highest and the second highest Exports(as % of merchandise exports) in North America?
Keep it short and to the point. 0.12. What is the difference between the highest and the second highest Exports(as % of merchandise exports) of Maldives?
Give a very brief answer. 4.12. What is the difference between the highest and the second highest Exports(as % of merchandise exports) in Papua New Guinea?
Ensure brevity in your answer.  1.57. What is the difference between the highest and the second highest Exports(as % of merchandise exports) in Philippines?
Ensure brevity in your answer.  0.52. What is the difference between the highest and the lowest Exports(as % of merchandise exports) of North America?
Keep it short and to the point. 17.79. What is the difference between the highest and the lowest Exports(as % of merchandise exports) in Maldives?
Ensure brevity in your answer.  42.26. What is the difference between the highest and the lowest Exports(as % of merchandise exports) of Papua New Guinea?
Make the answer very short. 4.5. What is the difference between the highest and the lowest Exports(as % of merchandise exports) in Philippines?
Make the answer very short. 32.88. 